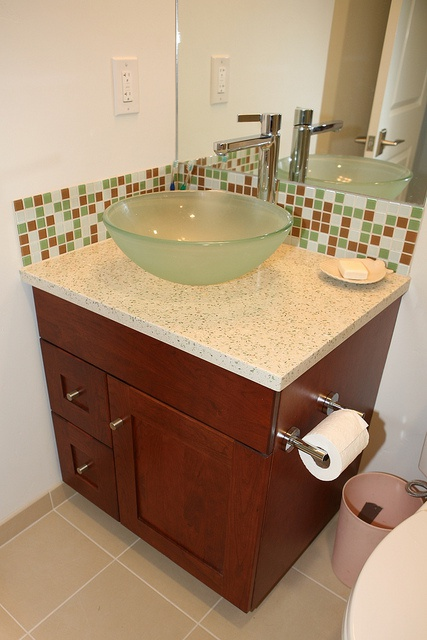Describe the objects in this image and their specific colors. I can see sink in tan tones, toilet in tan, lightgray, and gray tones, and bowl in tan and gray tones in this image. 